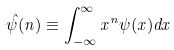<formula> <loc_0><loc_0><loc_500><loc_500>\hat { \psi } ( n ) \equiv \int _ { - \infty } ^ { \infty } x ^ { n } \psi ( x ) d x</formula> 